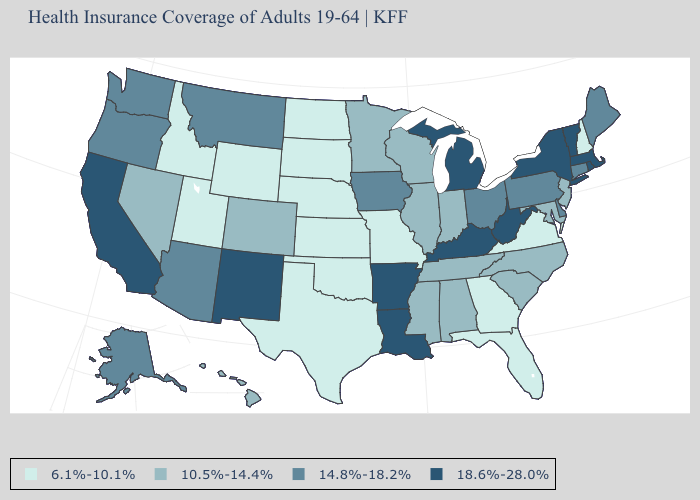Among the states that border California , which have the lowest value?
Concise answer only. Nevada. Name the states that have a value in the range 18.6%-28.0%?
Keep it brief. Arkansas, California, Kentucky, Louisiana, Massachusetts, Michigan, New Mexico, New York, Rhode Island, Vermont, West Virginia. How many symbols are there in the legend?
Keep it brief. 4. Which states have the lowest value in the MidWest?
Answer briefly. Kansas, Missouri, Nebraska, North Dakota, South Dakota. Does Tennessee have the lowest value in the USA?
Be succinct. No. Among the states that border New Hampshire , which have the lowest value?
Keep it brief. Maine. Does Mississippi have the lowest value in the USA?
Answer briefly. No. Which states hav the highest value in the MidWest?
Answer briefly. Michigan. Does Illinois have a lower value than Hawaii?
Write a very short answer. No. What is the value of Minnesota?
Keep it brief. 10.5%-14.4%. What is the lowest value in states that border Vermont?
Answer briefly. 6.1%-10.1%. Does North Carolina have the same value as Rhode Island?
Answer briefly. No. Does Hawaii have the lowest value in the West?
Write a very short answer. No. What is the value of Connecticut?
Short answer required. 14.8%-18.2%. What is the value of Wisconsin?
Give a very brief answer. 10.5%-14.4%. 